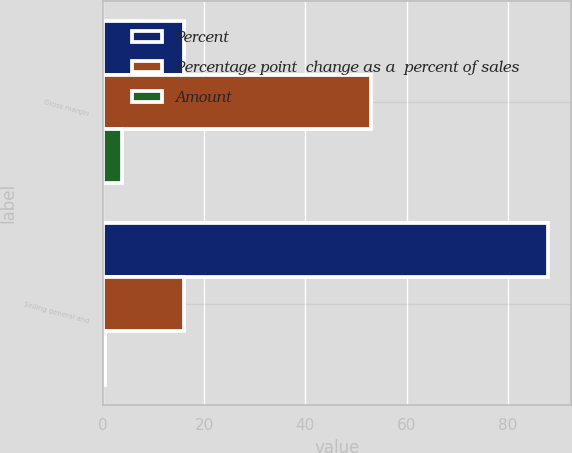<chart> <loc_0><loc_0><loc_500><loc_500><stacked_bar_chart><ecel><fcel>Gross margin<fcel>Selling general and<nl><fcel>Percent<fcel>16<fcel>88<nl><fcel>Percentage point  change as a  percent of sales<fcel>53<fcel>16<nl><fcel>Amount<fcel>3.8<fcel>0.5<nl></chart> 